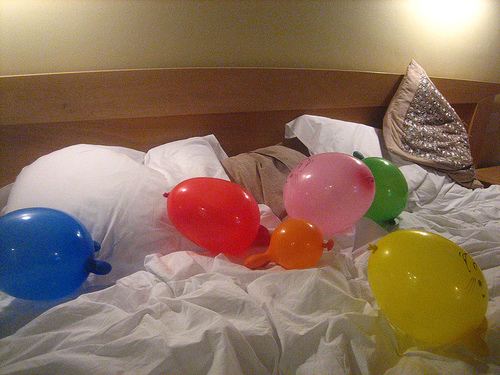<image>
Can you confirm if the balloon is under the pillow? No. The balloon is not positioned under the pillow. The vertical relationship between these objects is different. 